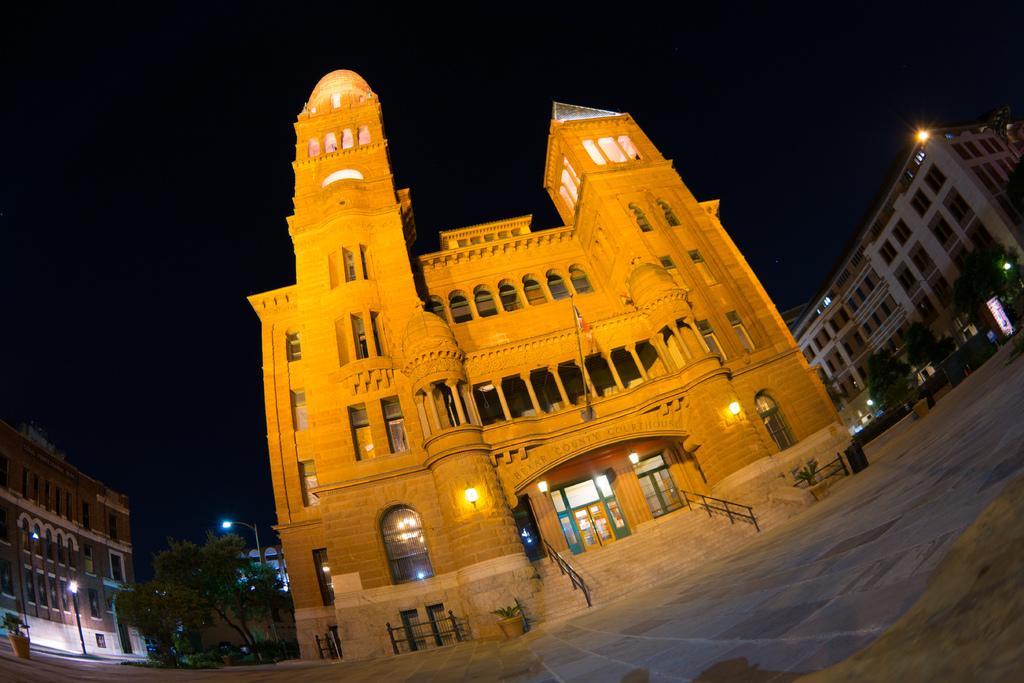How would you summarize this image in a sentence or two? This is the building with windows and pillars. Here is the flag hanging to the pole. These are the lamps, which are attached to the building wall. I can see glass doors. These are the stairs with staircase holders. There are two flower pots with plants in it. These are the pillars. I can see trees. These are the streetlights. I can see two buildings. 